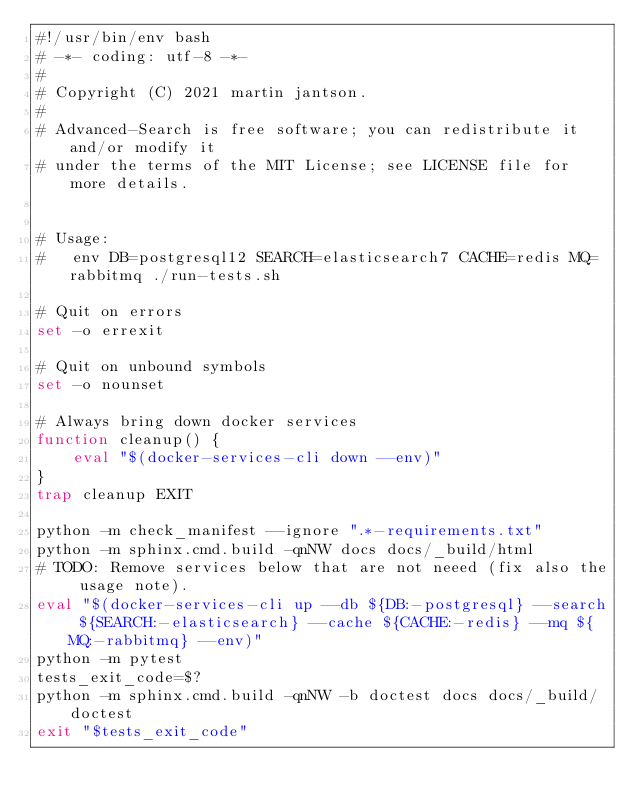<code> <loc_0><loc_0><loc_500><loc_500><_Bash_>#!/usr/bin/env bash
# -*- coding: utf-8 -*-
#
# Copyright (C) 2021 martin jantson.
#
# Advanced-Search is free software; you can redistribute it and/or modify it
# under the terms of the MIT License; see LICENSE file for more details.


# Usage:
#   env DB=postgresql12 SEARCH=elasticsearch7 CACHE=redis MQ=rabbitmq ./run-tests.sh

# Quit on errors
set -o errexit

# Quit on unbound symbols
set -o nounset

# Always bring down docker services
function cleanup() {
    eval "$(docker-services-cli down --env)"
}
trap cleanup EXIT

python -m check_manifest --ignore ".*-requirements.txt"
python -m sphinx.cmd.build -qnNW docs docs/_build/html
# TODO: Remove services below that are not neeed (fix also the usage note).
eval "$(docker-services-cli up --db ${DB:-postgresql} --search ${SEARCH:-elasticsearch} --cache ${CACHE:-redis} --mq ${MQ:-rabbitmq} --env)"
python -m pytest
tests_exit_code=$?
python -m sphinx.cmd.build -qnNW -b doctest docs docs/_build/doctest
exit "$tests_exit_code"
</code> 